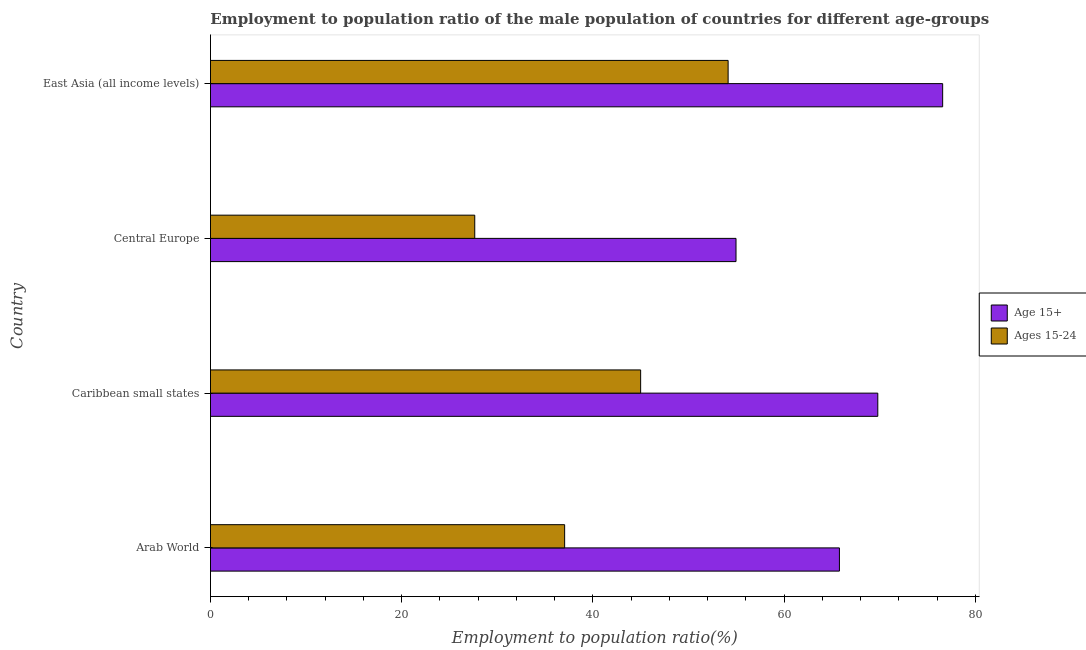How many groups of bars are there?
Offer a very short reply. 4. What is the label of the 2nd group of bars from the top?
Your answer should be very brief. Central Europe. What is the employment to population ratio(age 15+) in Central Europe?
Your answer should be very brief. 54.96. Across all countries, what is the maximum employment to population ratio(age 15+)?
Provide a succinct answer. 76.58. Across all countries, what is the minimum employment to population ratio(age 15-24)?
Keep it short and to the point. 27.64. In which country was the employment to population ratio(age 15+) maximum?
Offer a terse response. East Asia (all income levels). In which country was the employment to population ratio(age 15+) minimum?
Offer a terse response. Central Europe. What is the total employment to population ratio(age 15-24) in the graph?
Your answer should be compact. 163.81. What is the difference between the employment to population ratio(age 15+) in Arab World and that in East Asia (all income levels)?
Your answer should be very brief. -10.8. What is the difference between the employment to population ratio(age 15+) in East Asia (all income levels) and the employment to population ratio(age 15-24) in Arab World?
Your answer should be compact. 39.53. What is the average employment to population ratio(age 15-24) per country?
Ensure brevity in your answer.  40.95. What is the difference between the employment to population ratio(age 15-24) and employment to population ratio(age 15+) in East Asia (all income levels)?
Make the answer very short. -22.44. In how many countries, is the employment to population ratio(age 15+) greater than 12 %?
Make the answer very short. 4. What is the ratio of the employment to population ratio(age 15-24) in Central Europe to that in East Asia (all income levels)?
Your answer should be very brief. 0.51. What is the difference between the highest and the second highest employment to population ratio(age 15-24)?
Provide a succinct answer. 9.15. What is the difference between the highest and the lowest employment to population ratio(age 15-24)?
Keep it short and to the point. 26.5. In how many countries, is the employment to population ratio(age 15-24) greater than the average employment to population ratio(age 15-24) taken over all countries?
Give a very brief answer. 2. What does the 1st bar from the top in Central Europe represents?
Your response must be concise. Ages 15-24. What does the 2nd bar from the bottom in Caribbean small states represents?
Give a very brief answer. Ages 15-24. Are all the bars in the graph horizontal?
Your answer should be very brief. Yes. How many countries are there in the graph?
Ensure brevity in your answer.  4. Where does the legend appear in the graph?
Offer a very short reply. Center right. How are the legend labels stacked?
Provide a short and direct response. Vertical. What is the title of the graph?
Provide a short and direct response. Employment to population ratio of the male population of countries for different age-groups. What is the label or title of the X-axis?
Your answer should be compact. Employment to population ratio(%). What is the Employment to population ratio(%) in Age 15+ in Arab World?
Give a very brief answer. 65.78. What is the Employment to population ratio(%) of Ages 15-24 in Arab World?
Make the answer very short. 37.04. What is the Employment to population ratio(%) of Age 15+ in Caribbean small states?
Offer a very short reply. 69.79. What is the Employment to population ratio(%) in Ages 15-24 in Caribbean small states?
Offer a very short reply. 44.99. What is the Employment to population ratio(%) of Age 15+ in Central Europe?
Make the answer very short. 54.96. What is the Employment to population ratio(%) in Ages 15-24 in Central Europe?
Provide a short and direct response. 27.64. What is the Employment to population ratio(%) of Age 15+ in East Asia (all income levels)?
Your answer should be very brief. 76.58. What is the Employment to population ratio(%) in Ages 15-24 in East Asia (all income levels)?
Give a very brief answer. 54.14. Across all countries, what is the maximum Employment to population ratio(%) in Age 15+?
Keep it short and to the point. 76.58. Across all countries, what is the maximum Employment to population ratio(%) of Ages 15-24?
Your response must be concise. 54.14. Across all countries, what is the minimum Employment to population ratio(%) of Age 15+?
Offer a very short reply. 54.96. Across all countries, what is the minimum Employment to population ratio(%) of Ages 15-24?
Offer a very short reply. 27.64. What is the total Employment to population ratio(%) of Age 15+ in the graph?
Give a very brief answer. 267.11. What is the total Employment to population ratio(%) in Ages 15-24 in the graph?
Provide a succinct answer. 163.81. What is the difference between the Employment to population ratio(%) in Age 15+ in Arab World and that in Caribbean small states?
Provide a succinct answer. -4.01. What is the difference between the Employment to population ratio(%) in Ages 15-24 in Arab World and that in Caribbean small states?
Ensure brevity in your answer.  -7.95. What is the difference between the Employment to population ratio(%) of Age 15+ in Arab World and that in Central Europe?
Provide a succinct answer. 10.82. What is the difference between the Employment to population ratio(%) of Ages 15-24 in Arab World and that in Central Europe?
Your answer should be very brief. 9.4. What is the difference between the Employment to population ratio(%) of Age 15+ in Arab World and that in East Asia (all income levels)?
Give a very brief answer. -10.8. What is the difference between the Employment to population ratio(%) of Ages 15-24 in Arab World and that in East Asia (all income levels)?
Your answer should be compact. -17.1. What is the difference between the Employment to population ratio(%) in Age 15+ in Caribbean small states and that in Central Europe?
Your answer should be compact. 14.83. What is the difference between the Employment to population ratio(%) in Ages 15-24 in Caribbean small states and that in Central Europe?
Your answer should be compact. 17.35. What is the difference between the Employment to population ratio(%) of Age 15+ in Caribbean small states and that in East Asia (all income levels)?
Keep it short and to the point. -6.78. What is the difference between the Employment to population ratio(%) of Ages 15-24 in Caribbean small states and that in East Asia (all income levels)?
Give a very brief answer. -9.15. What is the difference between the Employment to population ratio(%) of Age 15+ in Central Europe and that in East Asia (all income levels)?
Give a very brief answer. -21.61. What is the difference between the Employment to population ratio(%) in Ages 15-24 in Central Europe and that in East Asia (all income levels)?
Your answer should be compact. -26.5. What is the difference between the Employment to population ratio(%) of Age 15+ in Arab World and the Employment to population ratio(%) of Ages 15-24 in Caribbean small states?
Offer a terse response. 20.79. What is the difference between the Employment to population ratio(%) in Age 15+ in Arab World and the Employment to population ratio(%) in Ages 15-24 in Central Europe?
Offer a very short reply. 38.14. What is the difference between the Employment to population ratio(%) in Age 15+ in Arab World and the Employment to population ratio(%) in Ages 15-24 in East Asia (all income levels)?
Keep it short and to the point. 11.64. What is the difference between the Employment to population ratio(%) of Age 15+ in Caribbean small states and the Employment to population ratio(%) of Ages 15-24 in Central Europe?
Ensure brevity in your answer.  42.15. What is the difference between the Employment to population ratio(%) of Age 15+ in Caribbean small states and the Employment to population ratio(%) of Ages 15-24 in East Asia (all income levels)?
Your answer should be very brief. 15.65. What is the difference between the Employment to population ratio(%) of Age 15+ in Central Europe and the Employment to population ratio(%) of Ages 15-24 in East Asia (all income levels)?
Offer a very short reply. 0.83. What is the average Employment to population ratio(%) in Age 15+ per country?
Give a very brief answer. 66.78. What is the average Employment to population ratio(%) in Ages 15-24 per country?
Make the answer very short. 40.95. What is the difference between the Employment to population ratio(%) in Age 15+ and Employment to population ratio(%) in Ages 15-24 in Arab World?
Provide a short and direct response. 28.74. What is the difference between the Employment to population ratio(%) in Age 15+ and Employment to population ratio(%) in Ages 15-24 in Caribbean small states?
Your answer should be compact. 24.8. What is the difference between the Employment to population ratio(%) in Age 15+ and Employment to population ratio(%) in Ages 15-24 in Central Europe?
Give a very brief answer. 27.32. What is the difference between the Employment to population ratio(%) of Age 15+ and Employment to population ratio(%) of Ages 15-24 in East Asia (all income levels)?
Provide a succinct answer. 22.44. What is the ratio of the Employment to population ratio(%) in Age 15+ in Arab World to that in Caribbean small states?
Keep it short and to the point. 0.94. What is the ratio of the Employment to population ratio(%) of Ages 15-24 in Arab World to that in Caribbean small states?
Your answer should be compact. 0.82. What is the ratio of the Employment to population ratio(%) of Age 15+ in Arab World to that in Central Europe?
Provide a short and direct response. 1.2. What is the ratio of the Employment to population ratio(%) in Ages 15-24 in Arab World to that in Central Europe?
Keep it short and to the point. 1.34. What is the ratio of the Employment to population ratio(%) in Age 15+ in Arab World to that in East Asia (all income levels)?
Give a very brief answer. 0.86. What is the ratio of the Employment to population ratio(%) of Ages 15-24 in Arab World to that in East Asia (all income levels)?
Make the answer very short. 0.68. What is the ratio of the Employment to population ratio(%) of Age 15+ in Caribbean small states to that in Central Europe?
Make the answer very short. 1.27. What is the ratio of the Employment to population ratio(%) in Ages 15-24 in Caribbean small states to that in Central Europe?
Provide a short and direct response. 1.63. What is the ratio of the Employment to population ratio(%) in Age 15+ in Caribbean small states to that in East Asia (all income levels)?
Your response must be concise. 0.91. What is the ratio of the Employment to population ratio(%) of Ages 15-24 in Caribbean small states to that in East Asia (all income levels)?
Your response must be concise. 0.83. What is the ratio of the Employment to population ratio(%) of Age 15+ in Central Europe to that in East Asia (all income levels)?
Make the answer very short. 0.72. What is the ratio of the Employment to population ratio(%) in Ages 15-24 in Central Europe to that in East Asia (all income levels)?
Give a very brief answer. 0.51. What is the difference between the highest and the second highest Employment to population ratio(%) of Age 15+?
Your response must be concise. 6.78. What is the difference between the highest and the second highest Employment to population ratio(%) of Ages 15-24?
Provide a short and direct response. 9.15. What is the difference between the highest and the lowest Employment to population ratio(%) of Age 15+?
Offer a terse response. 21.61. What is the difference between the highest and the lowest Employment to population ratio(%) of Ages 15-24?
Offer a terse response. 26.5. 